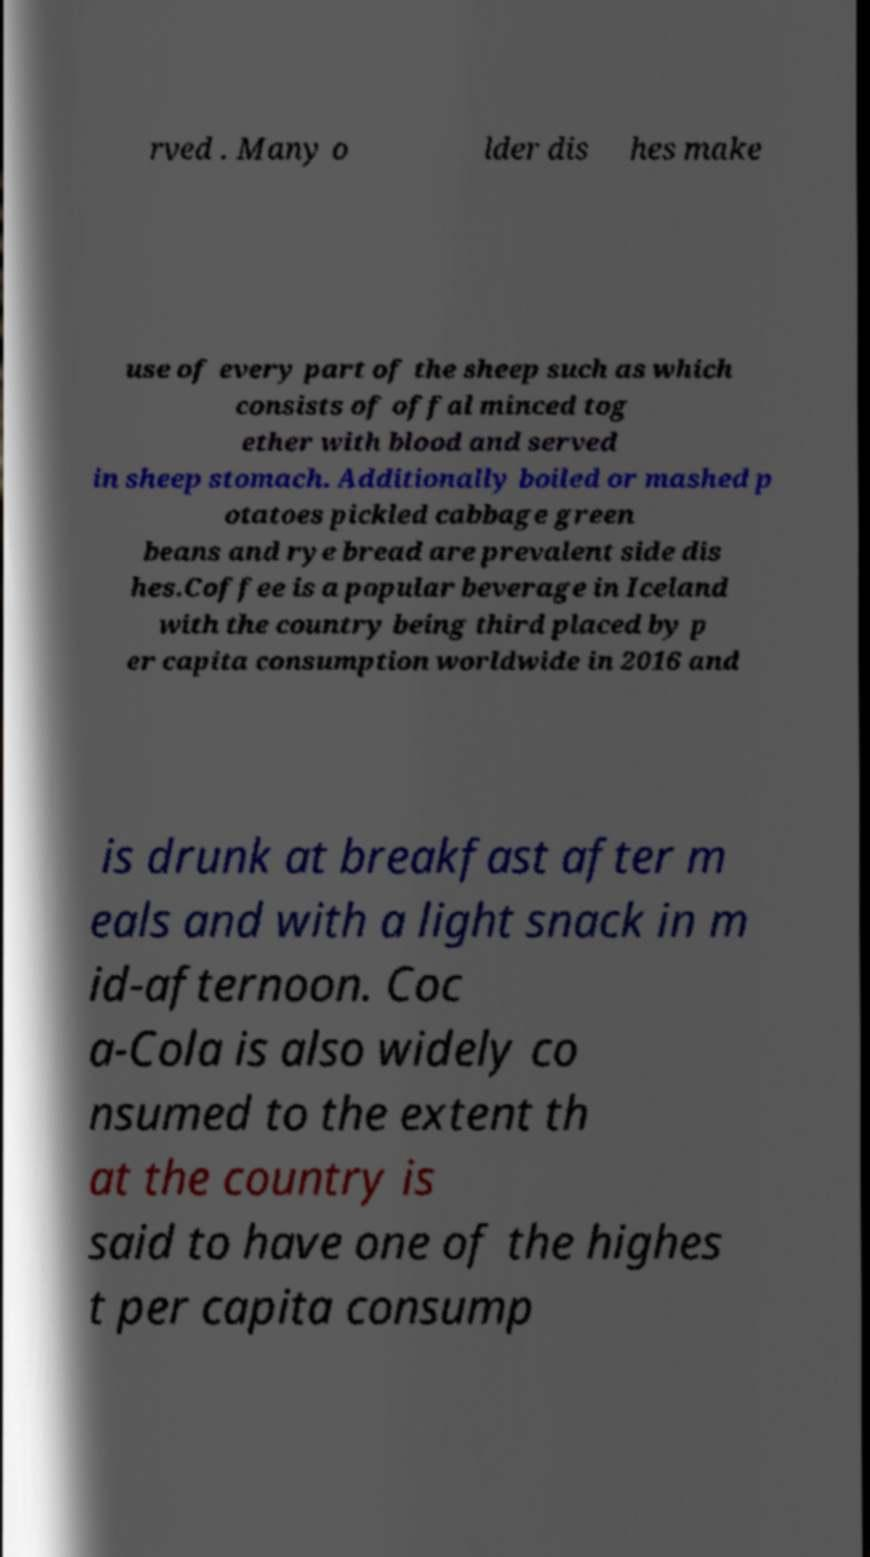There's text embedded in this image that I need extracted. Can you transcribe it verbatim? rved . Many o lder dis hes make use of every part of the sheep such as which consists of offal minced tog ether with blood and served in sheep stomach. Additionally boiled or mashed p otatoes pickled cabbage green beans and rye bread are prevalent side dis hes.Coffee is a popular beverage in Iceland with the country being third placed by p er capita consumption worldwide in 2016 and is drunk at breakfast after m eals and with a light snack in m id-afternoon. Coc a-Cola is also widely co nsumed to the extent th at the country is said to have one of the highes t per capita consump 